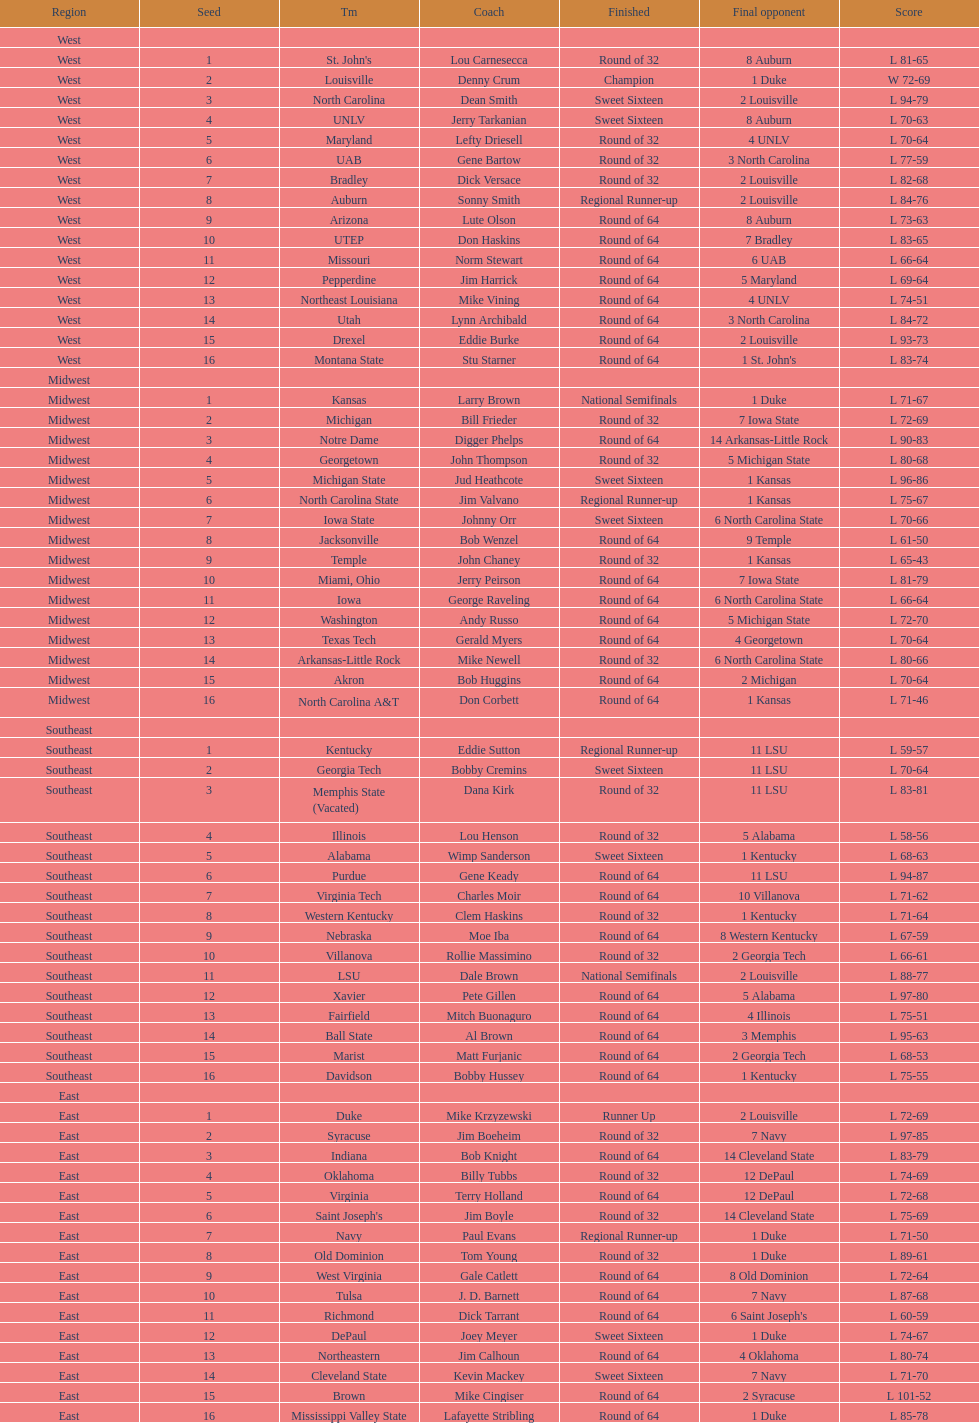What region is listed before the midwest? West. 